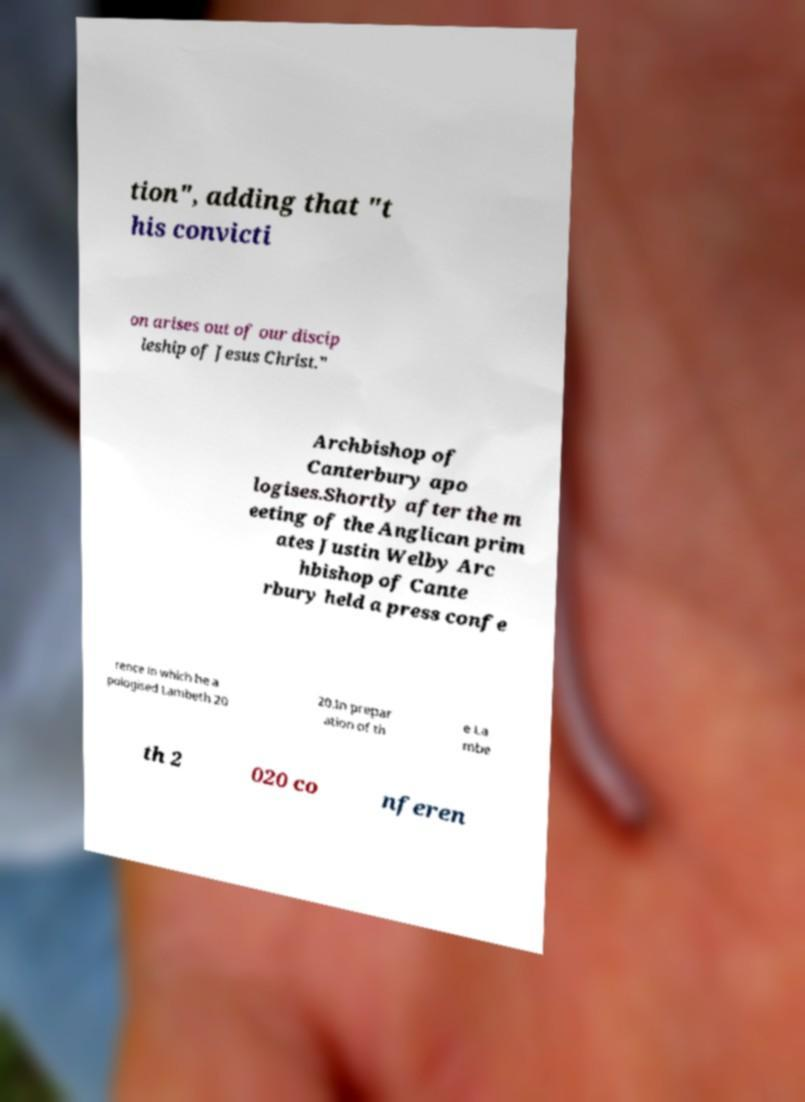Please identify and transcribe the text found in this image. tion", adding that "t his convicti on arises out of our discip leship of Jesus Christ." Archbishop of Canterbury apo logises.Shortly after the m eeting of the Anglican prim ates Justin Welby Arc hbishop of Cante rbury held a press confe rence in which he a pologised Lambeth 20 20.In prepar ation of th e La mbe th 2 020 co nferen 